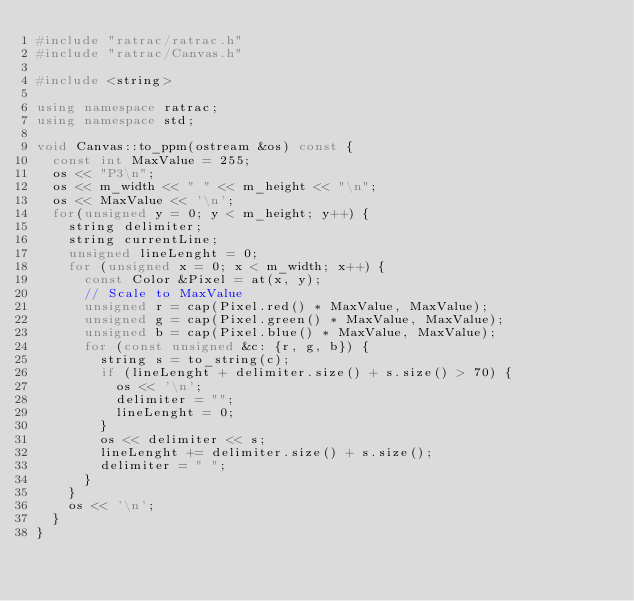<code> <loc_0><loc_0><loc_500><loc_500><_C++_>#include "ratrac/ratrac.h"
#include "ratrac/Canvas.h"

#include <string>

using namespace ratrac;
using namespace std;

void Canvas::to_ppm(ostream &os) const {
  const int MaxValue = 255;
  os << "P3\n";
  os << m_width << " " << m_height << "\n";
  os << MaxValue << '\n';
  for(unsigned y = 0; y < m_height; y++) {
    string delimiter;
    string currentLine;
    unsigned lineLenght = 0;
    for (unsigned x = 0; x < m_width; x++) {
      const Color &Pixel = at(x, y);
      // Scale to MaxValue
      unsigned r = cap(Pixel.red() * MaxValue, MaxValue);
      unsigned g = cap(Pixel.green() * MaxValue, MaxValue);
      unsigned b = cap(Pixel.blue() * MaxValue, MaxValue);
      for (const unsigned &c: {r, g, b}) {
        string s = to_string(c);
        if (lineLenght + delimiter.size() + s.size() > 70) {
          os << '\n';
          delimiter = "";
          lineLenght = 0;
        }
        os << delimiter << s;
        lineLenght += delimiter.size() + s.size();
        delimiter = " ";
      }
    }
    os << '\n';
  }
}
</code> 